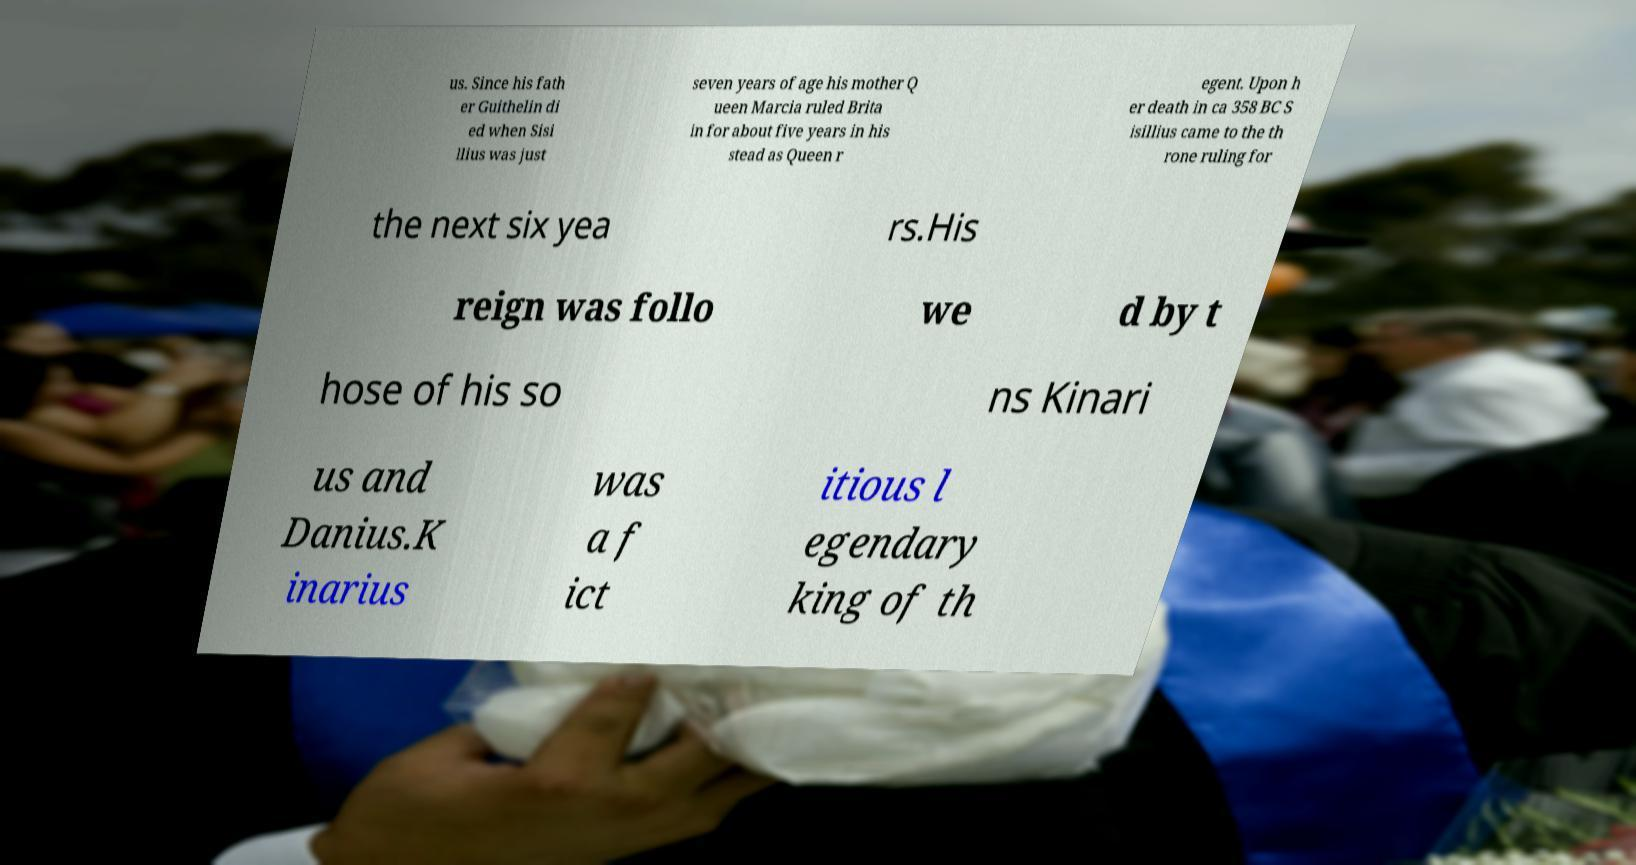Could you extract and type out the text from this image? us. Since his fath er Guithelin di ed when Sisi llius was just seven years of age his mother Q ueen Marcia ruled Brita in for about five years in his stead as Queen r egent. Upon h er death in ca 358 BC S isillius came to the th rone ruling for the next six yea rs.His reign was follo we d by t hose of his so ns Kinari us and Danius.K inarius was a f ict itious l egendary king of th 